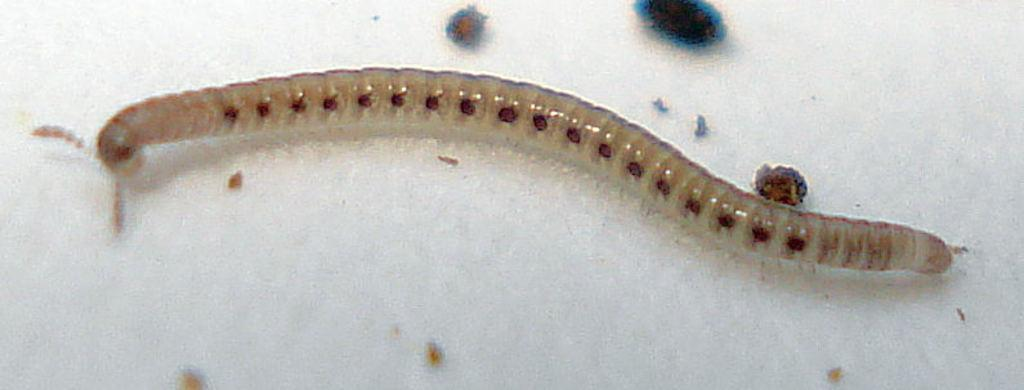What type of creature can be seen in the image? There is an insect in the image. Where is the insect located in relation to the image? The insect is in the background of the image. What color is the insect? The insect is white. What route does the insect take during the night in the image? There is no information about the insect's route or the time of day in the image, so we cannot determine this. 